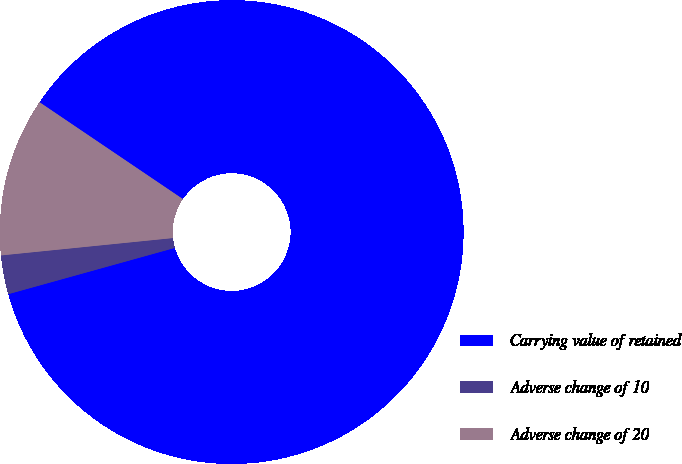Convert chart to OTSL. <chart><loc_0><loc_0><loc_500><loc_500><pie_chart><fcel>Carrying value of retained<fcel>Adverse change of 10<fcel>Adverse change of 20<nl><fcel>86.23%<fcel>2.71%<fcel>11.06%<nl></chart> 